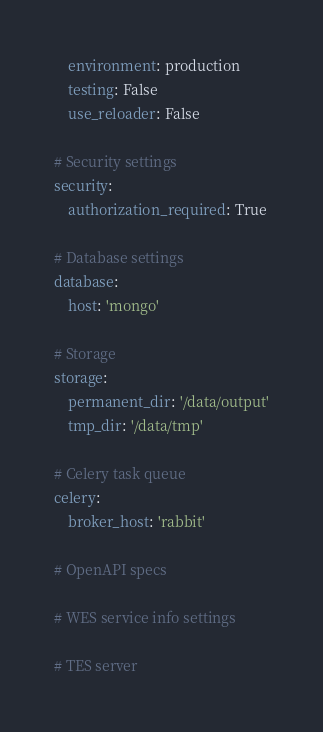Convert code to text. <code><loc_0><loc_0><loc_500><loc_500><_YAML_>    environment: production
    testing: False
    use_reloader: False

# Security settings
security:
    authorization_required: True

# Database settings
database:
    host: 'mongo'

# Storage
storage:
    permanent_dir: '/data/output'
    tmp_dir: '/data/tmp'

# Celery task queue
celery:
    broker_host: 'rabbit'

# OpenAPI specs

# WES service info settings

# TES server
</code> 